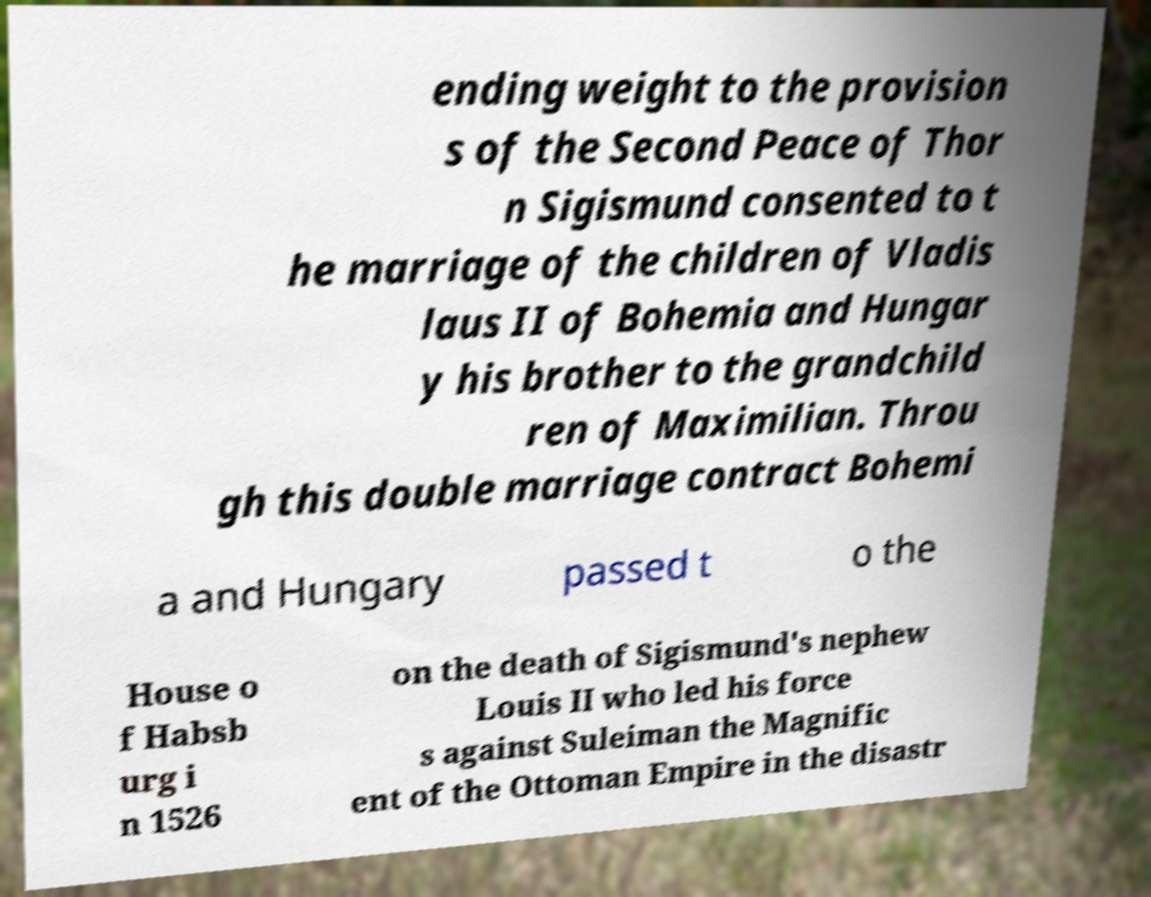Please read and relay the text visible in this image. What does it say? ending weight to the provision s of the Second Peace of Thor n Sigismund consented to t he marriage of the children of Vladis laus II of Bohemia and Hungar y his brother to the grandchild ren of Maximilian. Throu gh this double marriage contract Bohemi a and Hungary passed t o the House o f Habsb urg i n 1526 on the death of Sigismund's nephew Louis II who led his force s against Suleiman the Magnific ent of the Ottoman Empire in the disastr 